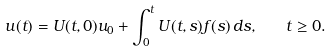Convert formula to latex. <formula><loc_0><loc_0><loc_500><loc_500>u ( t ) = U ( t , 0 ) u _ { 0 } + \int _ { 0 } ^ { t } U ( t , s ) f ( s ) \, d s , \quad t \geq 0 .</formula> 